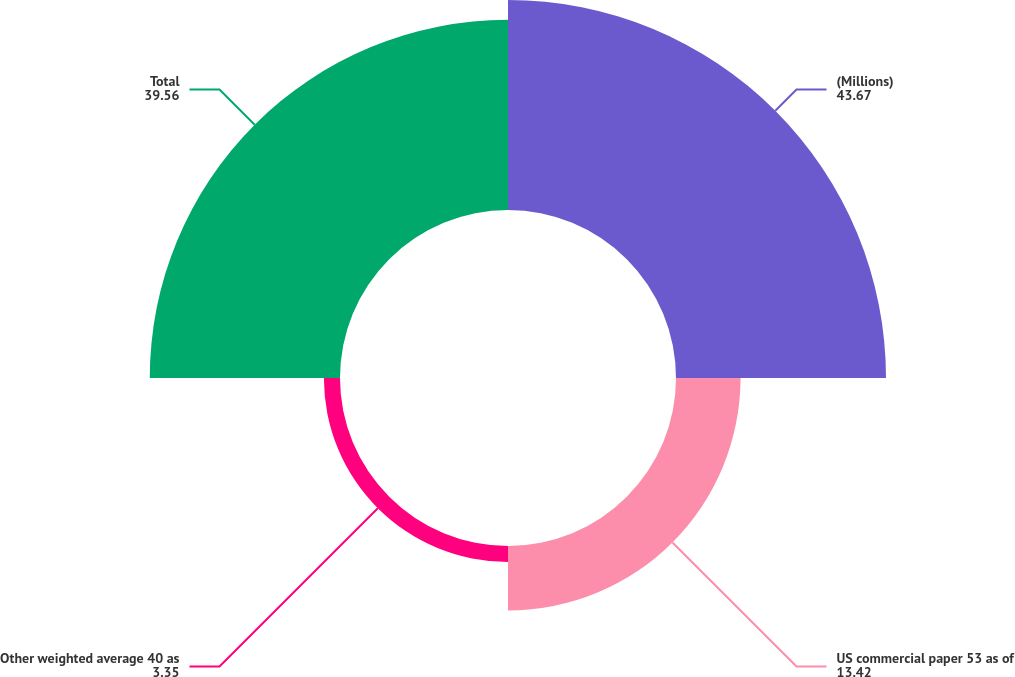Convert chart. <chart><loc_0><loc_0><loc_500><loc_500><pie_chart><fcel>(Millions)<fcel>US commercial paper 53 as of<fcel>Other weighted average 40 as<fcel>Total<nl><fcel>43.67%<fcel>13.42%<fcel>3.35%<fcel>39.56%<nl></chart> 